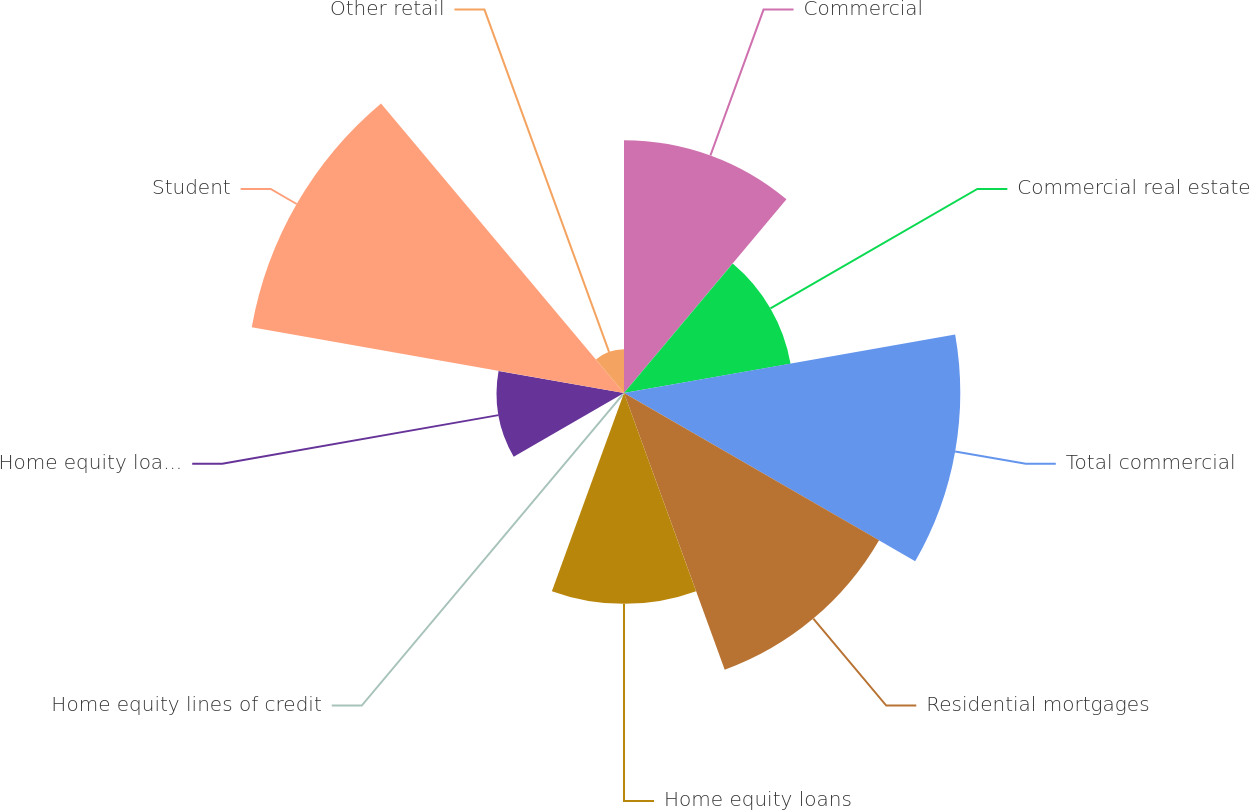Convert chart to OTSL. <chart><loc_0><loc_0><loc_500><loc_500><pie_chart><fcel>Commercial<fcel>Commercial real estate<fcel>Total commercial<fcel>Residential mortgages<fcel>Home equity loans<fcel>Home equity lines of credit<fcel>Home equity loans serviced by<fcel>Student<fcel>Other retail<nl><fcel>13.93%<fcel>9.32%<fcel>18.53%<fcel>16.23%<fcel>11.62%<fcel>0.11%<fcel>7.02%<fcel>20.83%<fcel>2.41%<nl></chart> 